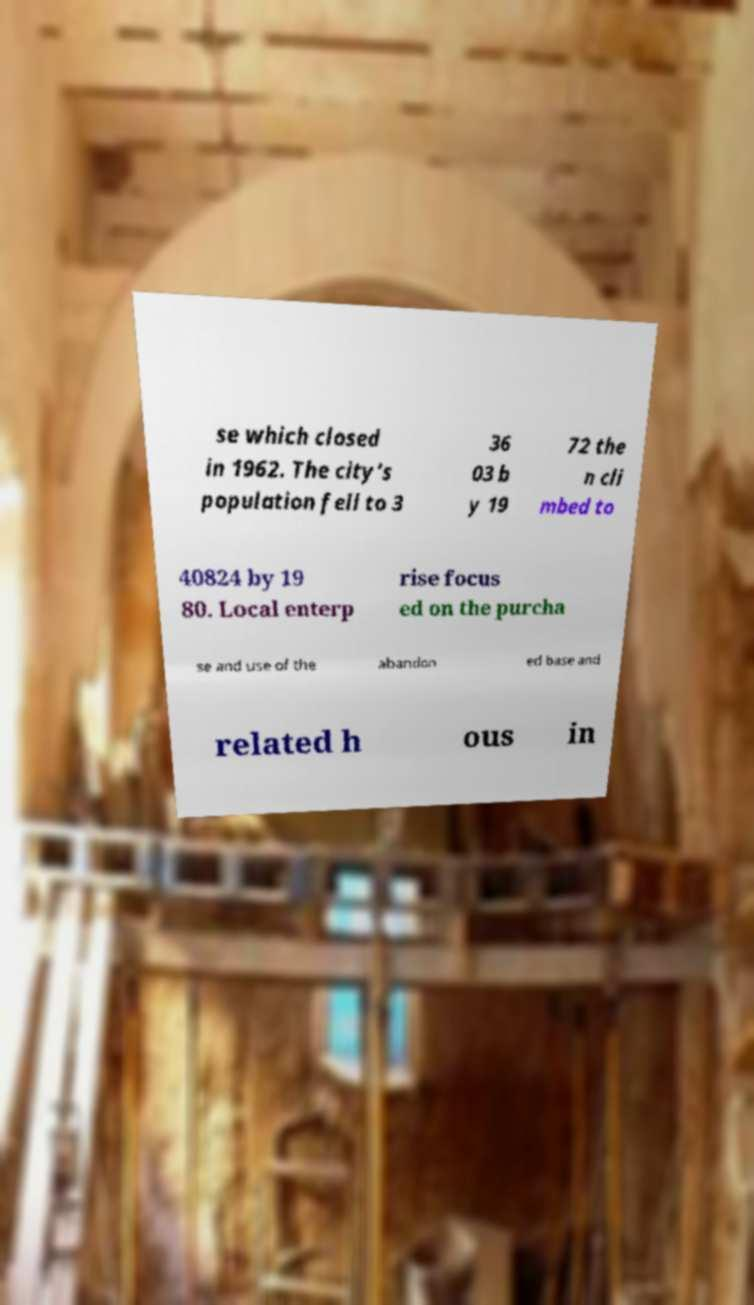There's text embedded in this image that I need extracted. Can you transcribe it verbatim? se which closed in 1962. The city's population fell to 3 36 03 b y 19 72 the n cli mbed to 40824 by 19 80. Local enterp rise focus ed on the purcha se and use of the abandon ed base and related h ous in 